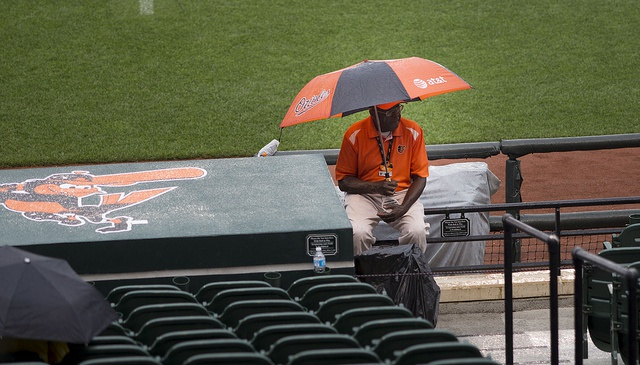Describe the objects in this image and their specific colors. I can see people in darkgreen, brown, maroon, black, and gray tones, umbrella in darkgreen, gray, and salmon tones, people in darkgreen, black, and gray tones, chair in darkgreen, black, gray, darkgray, and purple tones, and chair in darkgreen, black, gray, and purple tones in this image. 